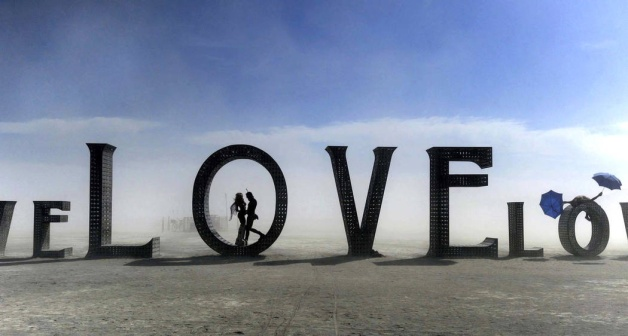What could be the symbolic meaning of each person's placement and actions within the image? The couple, entwined within the 'O', symbolizes being encapsulated in love, surrounded and protected by its shape. The person walking with an umbrella, distanced from this intimate portrayal, might represent isolation or the journey of seeking love. This contrast evokes a powerful narrative on human relationships and the various stages of experiencing love. How does the atmosphere contribute to the overall theme of the image? The hazy sky and the vast, uncluttered landscape contribute to a sense of emptiness and infinity, suggesting that despite the barrenness around, the emotion of love provides depth and fulfillment. The atmosphere acts as a canvas, emphasizing the starkness of the letters and the warmth of the human connection. 